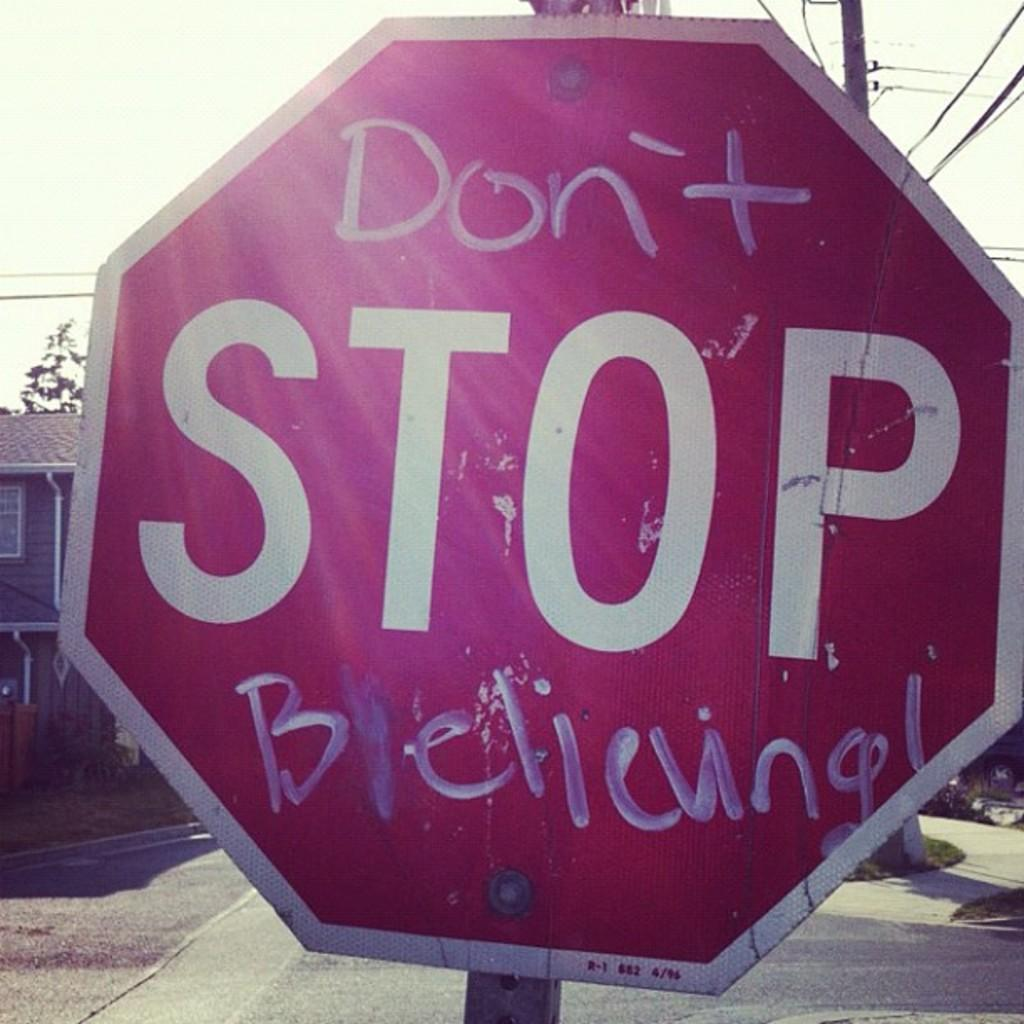What is the color of the board in the image? The board in the image is red. What is on the board? Something is written on the board. What can be seen in the background of the image? There is a building, a pole, and wires in the background of the image. What type of haircut is the person getting in the image? There is no person getting a haircut in the image. How many vacation days does the person have, as mentioned on the board? The board does not mention any vacation days; it only states that something is written on it. 